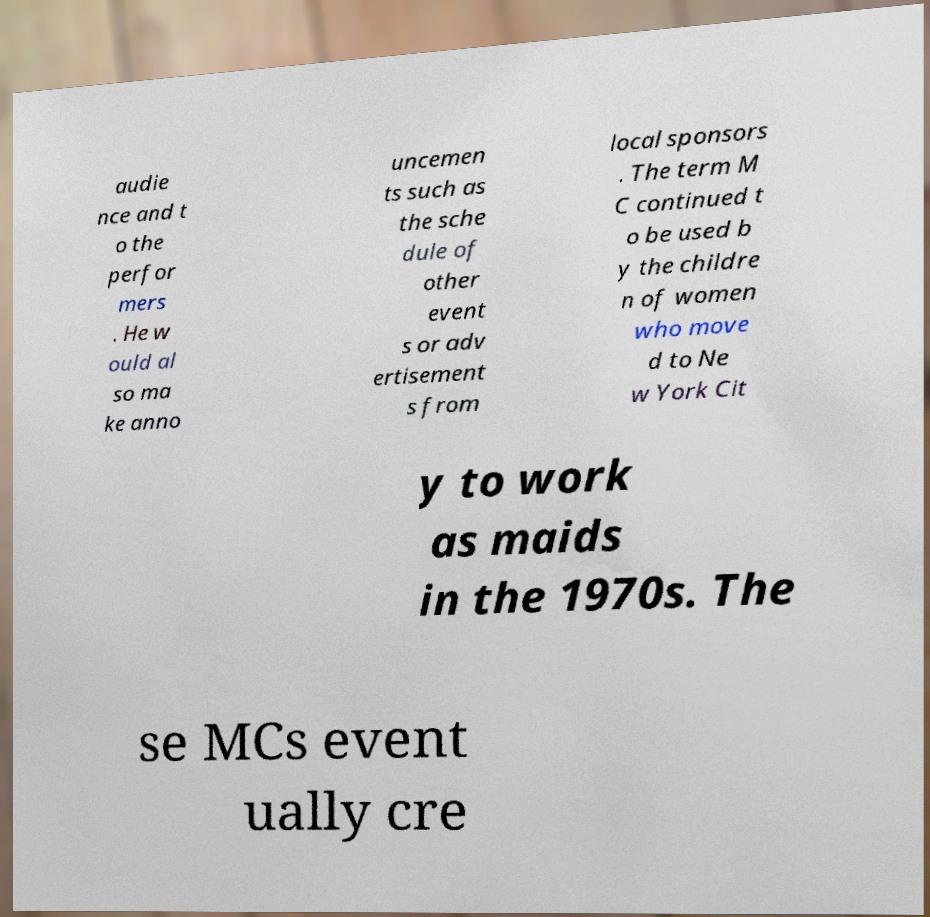Please read and relay the text visible in this image. What does it say? audie nce and t o the perfor mers . He w ould al so ma ke anno uncemen ts such as the sche dule of other event s or adv ertisement s from local sponsors . The term M C continued t o be used b y the childre n of women who move d to Ne w York Cit y to work as maids in the 1970s. The se MCs event ually cre 